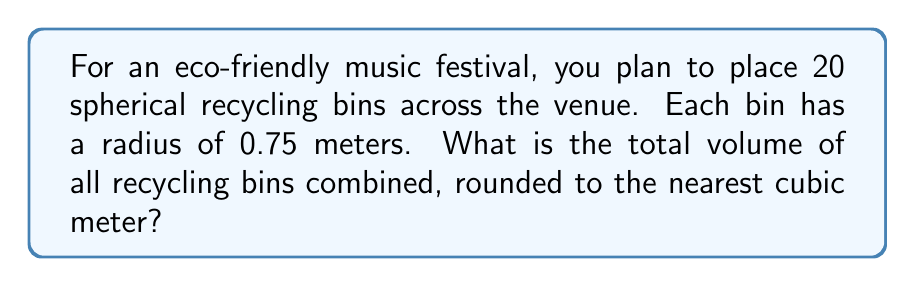Can you answer this question? Let's approach this step-by-step:

1) The volume of a sphere is given by the formula:
   
   $$V = \frac{4}{3}\pi r^3$$

   Where $r$ is the radius of the sphere.

2) We're given that each bin has a radius of 0.75 meters. Let's substitute this into our formula:

   $$V = \frac{4}{3}\pi (0.75)^3$$

3) Let's calculate this:
   
   $$V = \frac{4}{3}\pi (0.421875)$$
   $$V \approx 1.767146 \text{ m}^3$$

4) This is the volume of one bin. We need to multiply this by the total number of bins (20):

   $$\text{Total Volume} = 20 \times 1.767146$$
   $$\text{Total Volume} = 35.34292 \text{ m}^3$$

5) Rounding to the nearest cubic meter:

   $$\text{Total Volume} \approx 35 \text{ m}^3$$
Answer: 35 m³ 